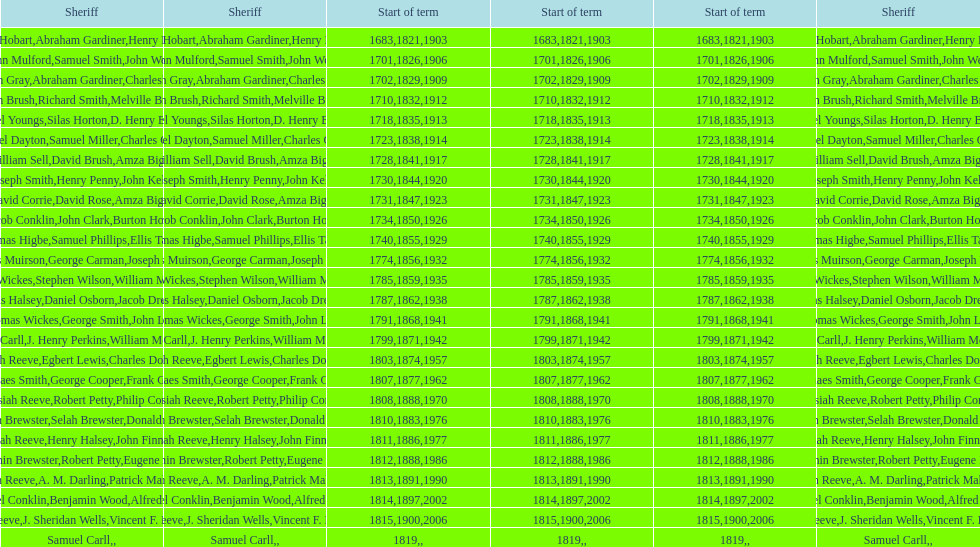Did robert petty serve before josiah reeve? No. 